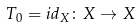Convert formula to latex. <formula><loc_0><loc_0><loc_500><loc_500>T _ { 0 } = i d _ { X } \colon X \rightarrow X</formula> 